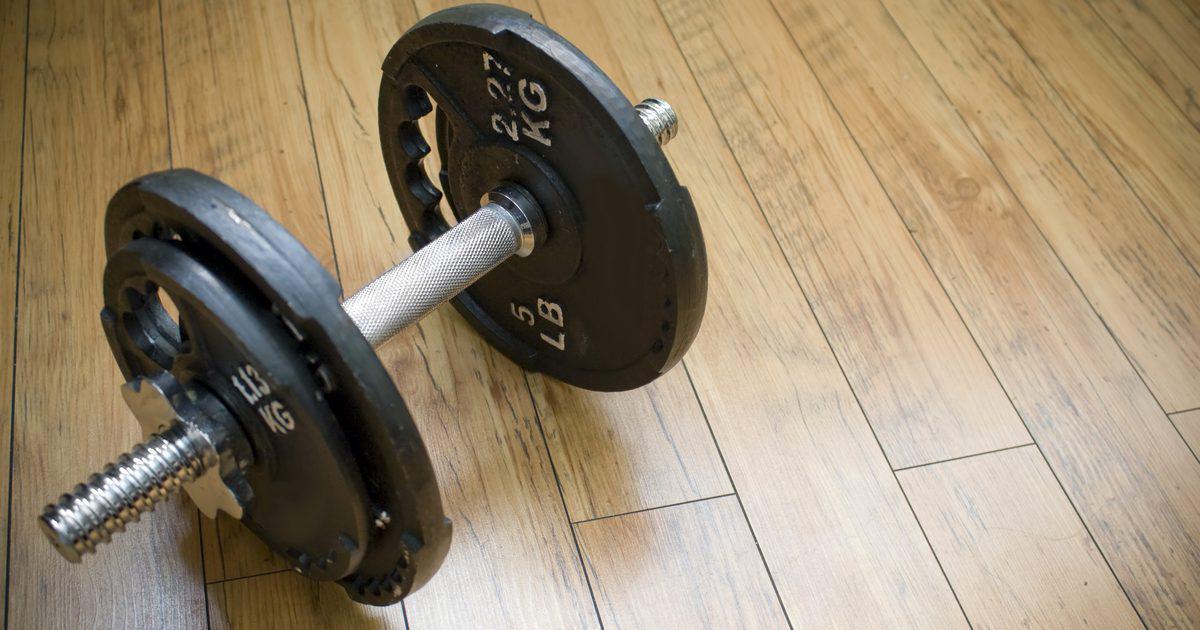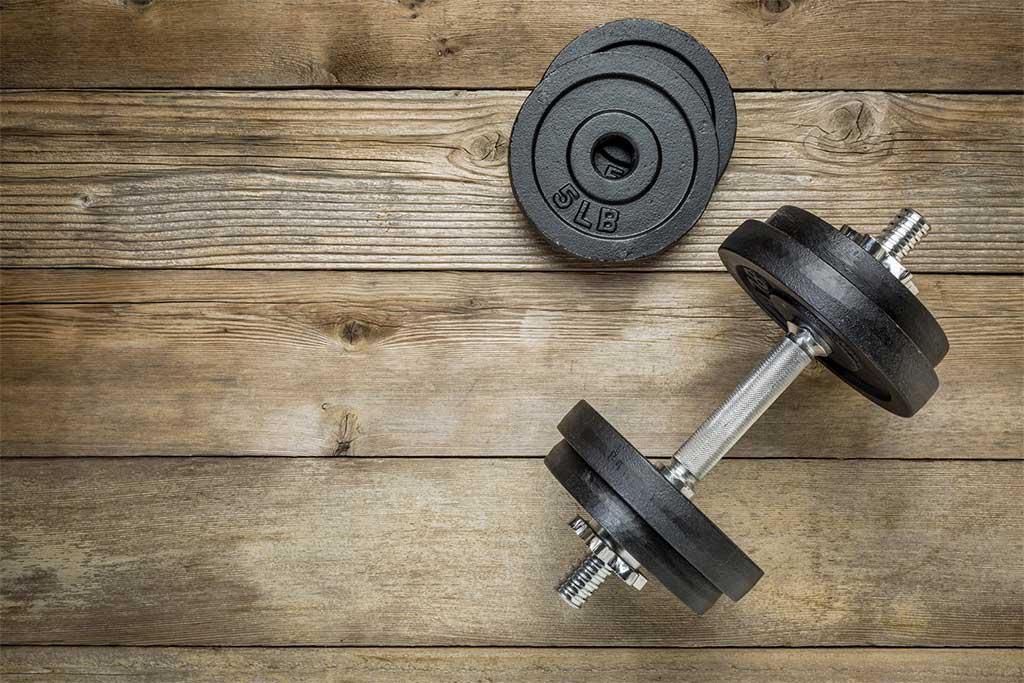The first image is the image on the left, the second image is the image on the right. Examine the images to the left and right. Is the description "In at least one image there is a person sitting and working out with weights." accurate? Answer yes or no. No. The first image is the image on the left, the second image is the image on the right. For the images displayed, is the sentence "In the image on the left, at least 8 dumbbells are stored against a wall sitting in a straight line." factually correct? Answer yes or no. No. 